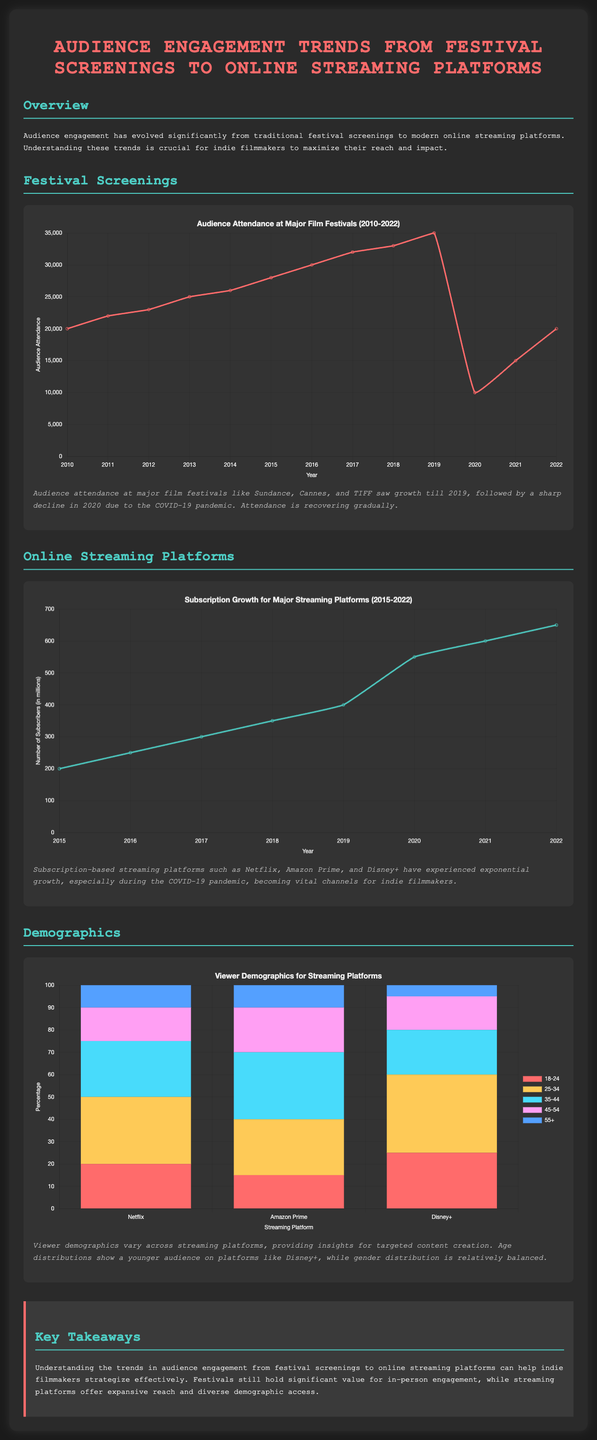what was the audience attendance in 2019? The audience attendance in 2019 was 35000, as shown in the festival screenings chart.
Answer: 35000 how many subscribers did streaming platforms have in 2021? The number of subscribers in 2021 was 600 million, indicated in the streaming chart.
Answer: 600 million which age group has the highest percentage on Disney+? The age group 25-34 has the highest percentage on Disney+, as shown in the demographics chart.
Answer: 35 what year saw the lowest audience attendance at festivals? The year with the lowest attendance was 2020, due to the decline in attendance caused by the pandemic.
Answer: 2020 how many major streaming platforms are compared in the demographics section? The demographics section compares three major streaming platforms: Netflix, Amazon Prime, and Disney+.
Answer: three what trend does the audience attendance show after 2020? The attendance is recovering gradually, suggesting a slow upward trend post-2020 as indicated in the festival screenings description.
Answer: recovering gradually what was the growth of subscribers from 2019 to 2020? The growth of subscribers increased from 400 million in 2019 to 550 million in 2020, as shown in the streaming chart.
Answer: 150 million which demographic group has the least representation on Disney+? The least represented group on Disney+ is the 55+ age group, according to the demographics chart.
Answer: 5 